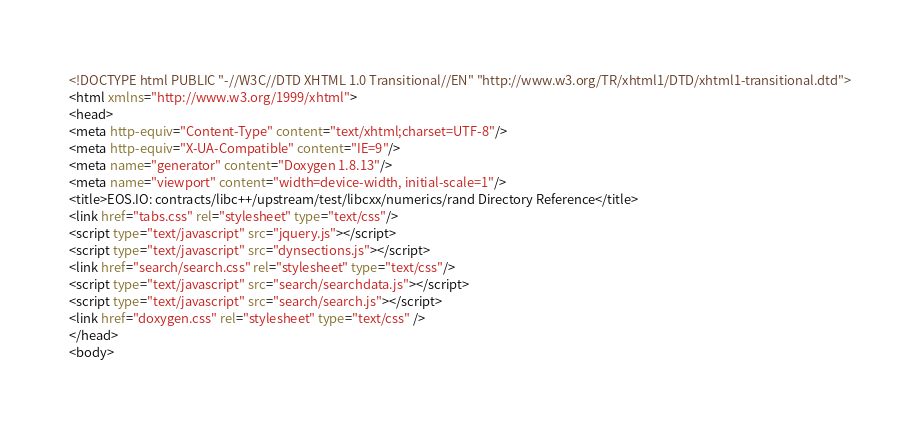Convert code to text. <code><loc_0><loc_0><loc_500><loc_500><_HTML_><!DOCTYPE html PUBLIC "-//W3C//DTD XHTML 1.0 Transitional//EN" "http://www.w3.org/TR/xhtml1/DTD/xhtml1-transitional.dtd">
<html xmlns="http://www.w3.org/1999/xhtml">
<head>
<meta http-equiv="Content-Type" content="text/xhtml;charset=UTF-8"/>
<meta http-equiv="X-UA-Compatible" content="IE=9"/>
<meta name="generator" content="Doxygen 1.8.13"/>
<meta name="viewport" content="width=device-width, initial-scale=1"/>
<title>EOS.IO: contracts/libc++/upstream/test/libcxx/numerics/rand Directory Reference</title>
<link href="tabs.css" rel="stylesheet" type="text/css"/>
<script type="text/javascript" src="jquery.js"></script>
<script type="text/javascript" src="dynsections.js"></script>
<link href="search/search.css" rel="stylesheet" type="text/css"/>
<script type="text/javascript" src="search/searchdata.js"></script>
<script type="text/javascript" src="search/search.js"></script>
<link href="doxygen.css" rel="stylesheet" type="text/css" />
</head>
<body></code> 